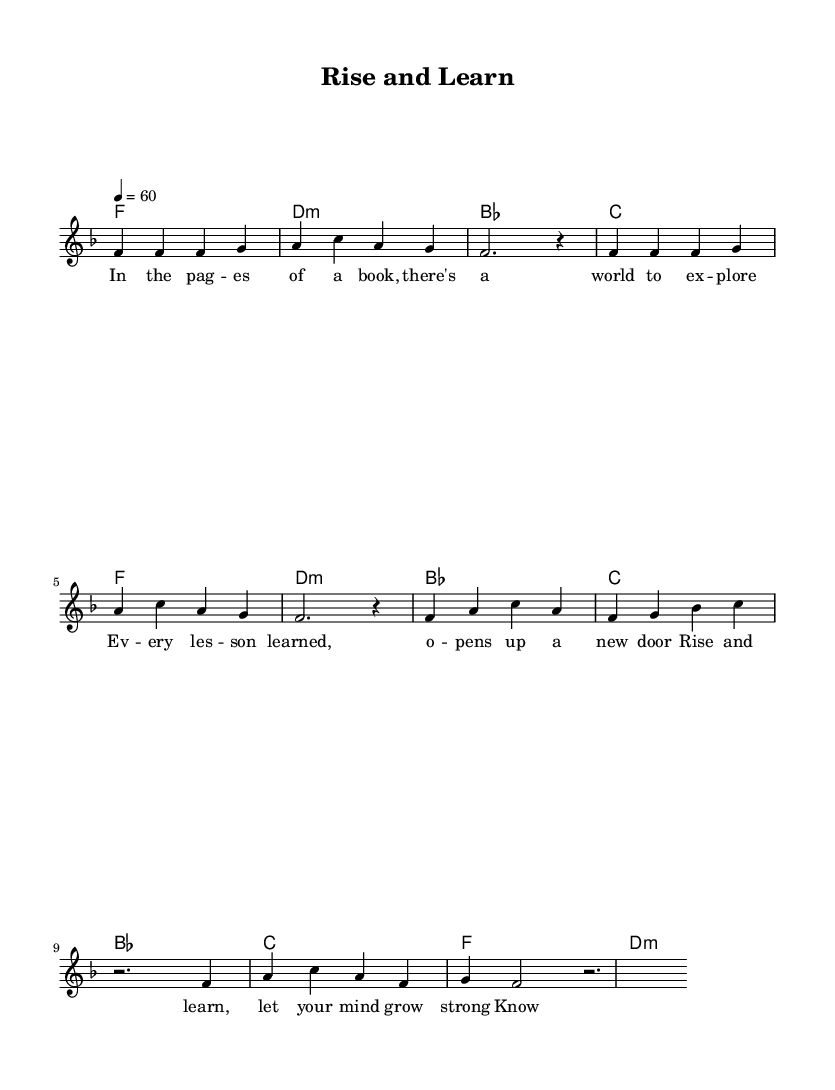What is the key signature of this music? The key signature is F major, which has one flat. You can determine this by looking at the key indicated at the beginning of the score, which is noted as "f."
Answer: F major What is the time signature of the piece? The time signature is 4/4, which is indicated at the beginning of the score. This tells us that there are four beats in each measure.
Answer: 4/4 What is the tempo marking? The tempo marking is 60 beats per minute, as noted in the score. This indicates the pace at which the piece should be played.
Answer: 60 How many measures are there in the verse? There are eight measures in the verse section, as counted from the beginning of the verse lyrics to the end of the verse.
Answer: 8 What chord is played during the first measure of the chorus? The first measure of the chorus features the B flat major chord, noted in the chord changes above the melody line.
Answer: B flat What theme is explored in the lyrics of this ballad? The lyrics focus on the importance of education and personal growth, as suggested by phrases that refer to learning and knowledge.
Answer: Education and personal growth Which section contains a rest? The chorus contains a two-beat rest, indicated between the chord changes and melody notes. This rest allows for a pause in the music.
Answer: Chorus 